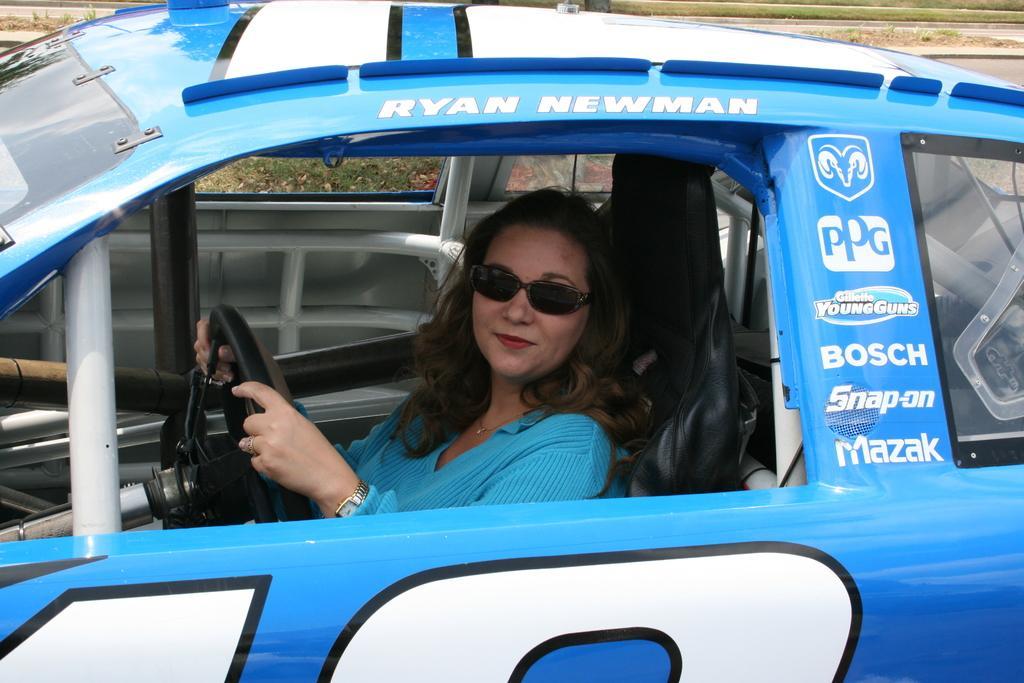Describe this image in one or two sentences. In this picture we can see women wore google, watch and smiling and holding steering with her hand and she is inside the car. 